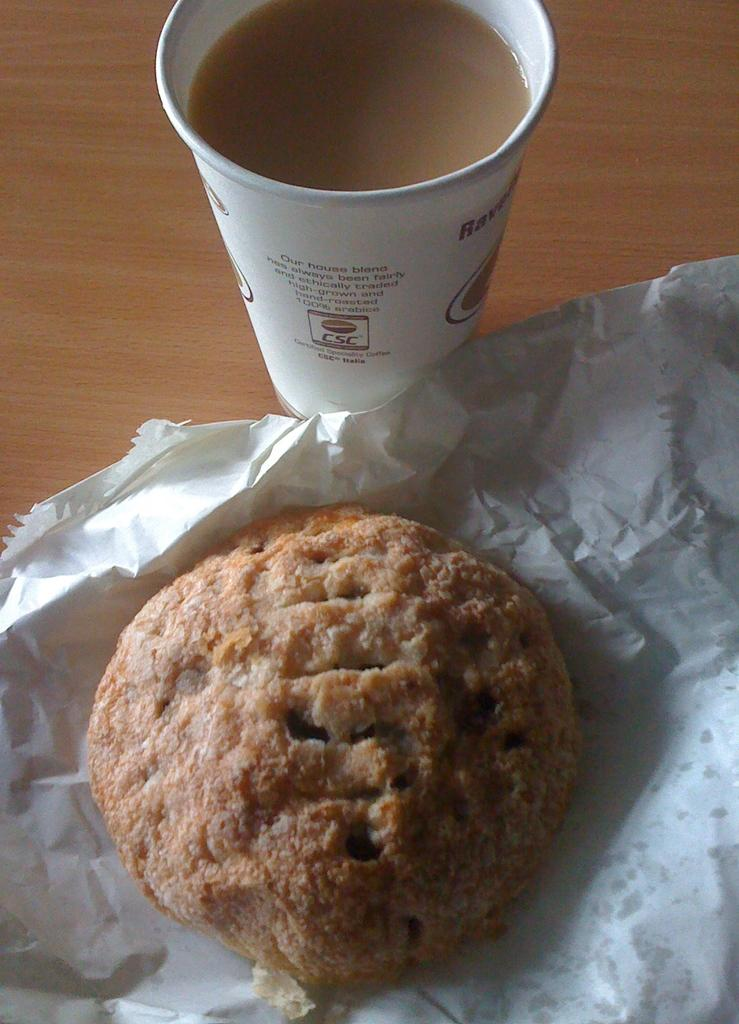What is in the cup that is visible in the image? There is a cup of tea in the image. What type of food is present in the image? There is a biscuit in the image. What other item can be seen in the image besides the tea and biscuit? There is a paper in the image. Where are all of these items located in the image? All of these items are on a table. What is the current temperature in the image? The image does not provide information about the current temperature. What color are the eyes of the person in the image? There is no person present in the image, so it is not possible to determine the color of their eyes. 